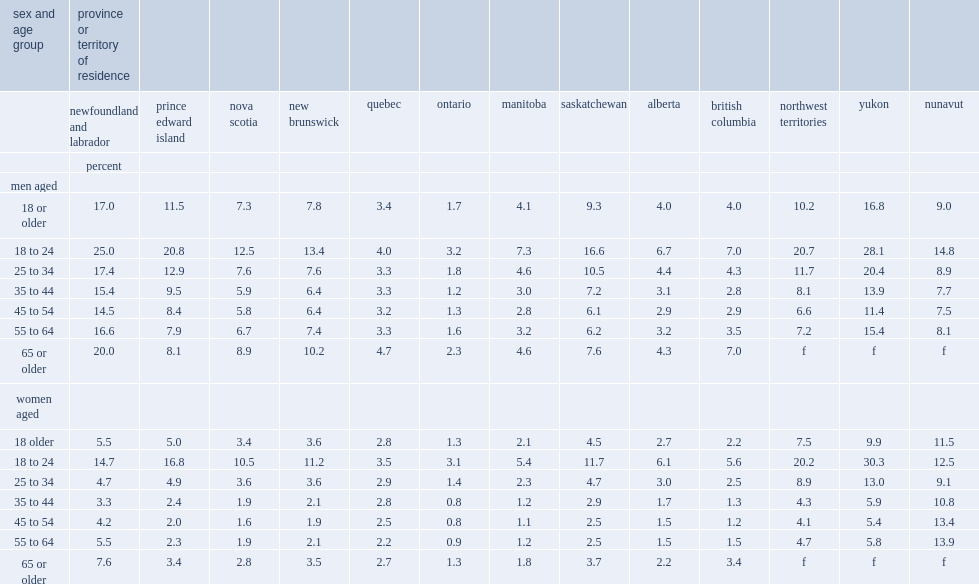What is the averaged percentage of the incidence of interprovincial employment among males in newfoundland and labrador during the 2002-to-2011 period? 17.0. How many times is the incidence of interprovincial employment among males in newfoundland and labrador than the rate among women? 3.090909. How many times is the rate of interprovincial employment among men than that among women for prince edward island? 2.3. How many times is the rate of interprovincial employment among men than that among women for nova scotia? 2.027778. How many times is the rate of interprovincial employment among men than that among women for new brunswick? 2.166667. How many times is the rate of interprovincial employment among men than that among women for manitoba? 1.952381. How many times is the rate of interprovincial employment among men than that among women for saskatchewan? 2.066667. Which women age group is more likely to be interprovincial employees for all provinces and territories except nunavut, 18 to 24 or 25 or older? 18 to 24. Which men age group is more likely to be involved in interprovincial employment for all provinces and territories except quebec and yukon, 18 to 24 or 25 or older? 18 to 24. 